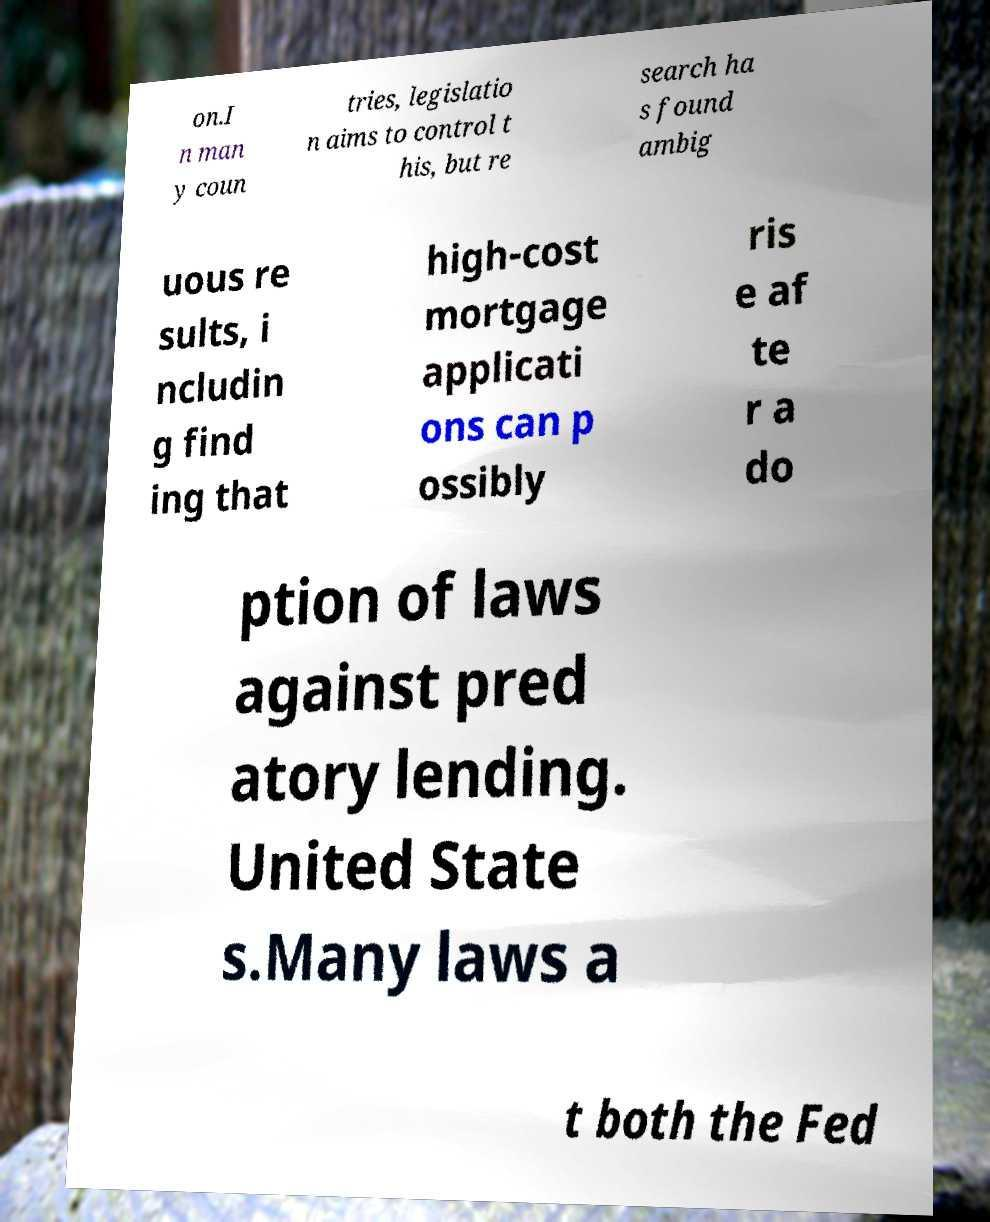There's text embedded in this image that I need extracted. Can you transcribe it verbatim? on.I n man y coun tries, legislatio n aims to control t his, but re search ha s found ambig uous re sults, i ncludin g find ing that high-cost mortgage applicati ons can p ossibly ris e af te r a do ption of laws against pred atory lending. United State s.Many laws a t both the Fed 